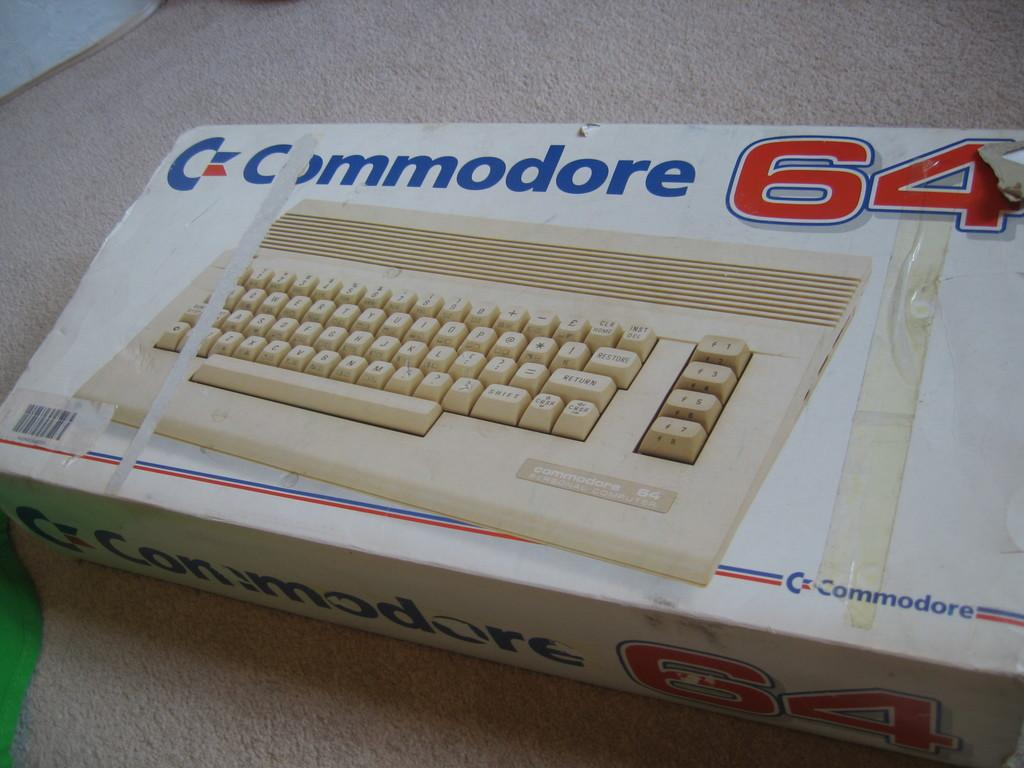<image>
Provide a brief description of the given image. A box for a Commodore 64 games console on a carpet. 